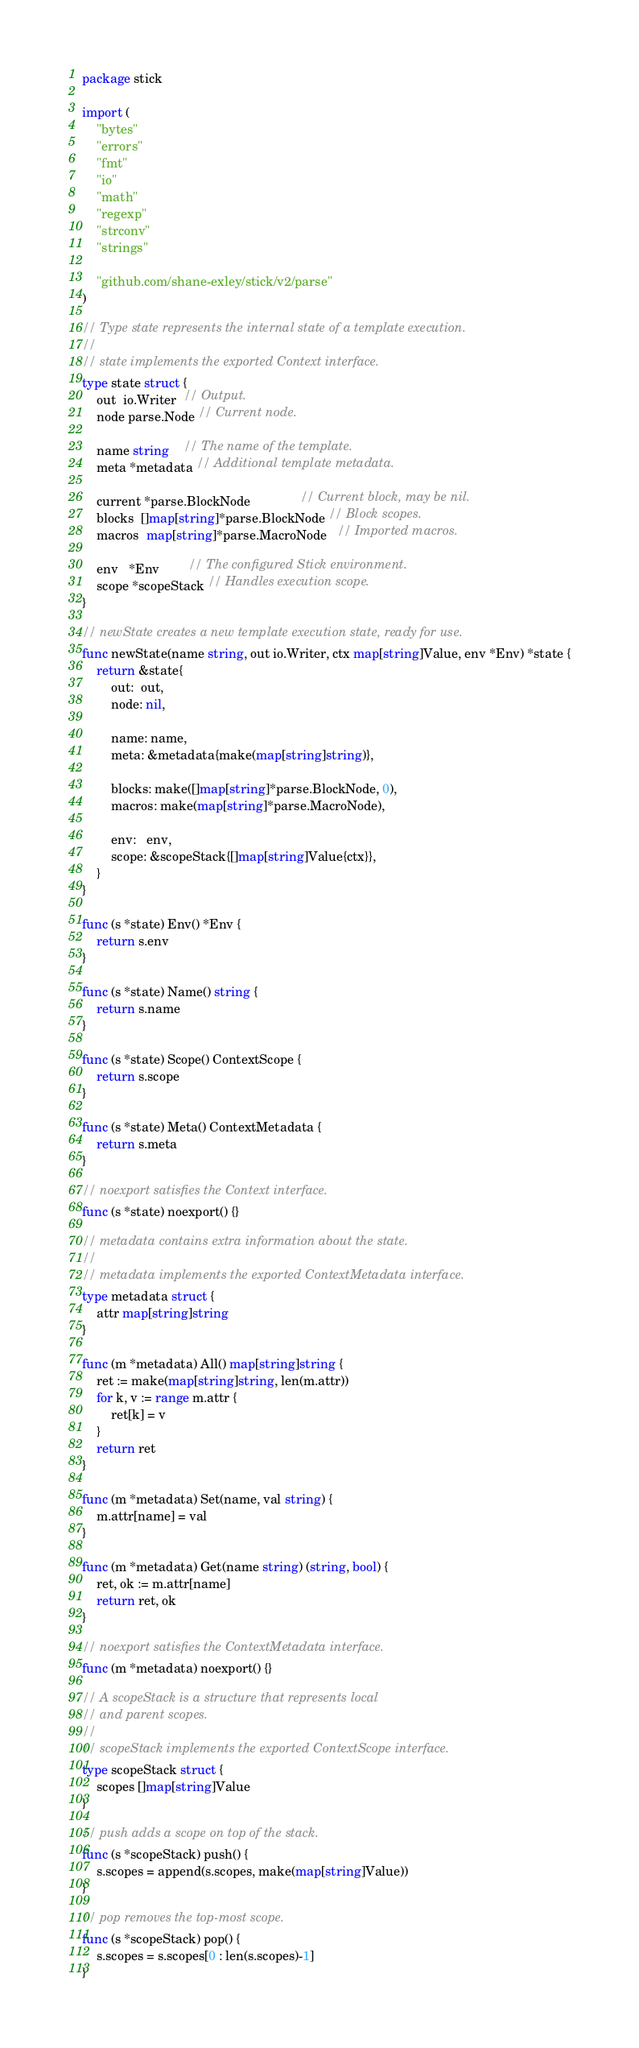Convert code to text. <code><loc_0><loc_0><loc_500><loc_500><_Go_>package stick

import (
	"bytes"
	"errors"
	"fmt"
	"io"
	"math"
	"regexp"
	"strconv"
	"strings"

	"github.com/shane-exley/stick/v2/parse"
)

// Type state represents the internal state of a template execution.
//
// state implements the exported Context interface.
type state struct {
	out  io.Writer  // Output.
	node parse.Node // Current node.

	name string    // The name of the template.
	meta *metadata // Additional template metadata.

	current *parse.BlockNode              // Current block, may be nil.
	blocks  []map[string]*parse.BlockNode // Block scopes.
	macros  map[string]*parse.MacroNode   // Imported macros.

	env   *Env        // The configured Stick environment.
	scope *scopeStack // Handles execution scope.
}

// newState creates a new template execution state, ready for use.
func newState(name string, out io.Writer, ctx map[string]Value, env *Env) *state {
	return &state{
		out:  out,
		node: nil,

		name: name,
		meta: &metadata{make(map[string]string)},

		blocks: make([]map[string]*parse.BlockNode, 0),
		macros: make(map[string]*parse.MacroNode),

		env:   env,
		scope: &scopeStack{[]map[string]Value{ctx}},
	}
}

func (s *state) Env() *Env {
	return s.env
}

func (s *state) Name() string {
	return s.name
}

func (s *state) Scope() ContextScope {
	return s.scope
}

func (s *state) Meta() ContextMetadata {
	return s.meta
}

// noexport satisfies the Context interface.
func (s *state) noexport() {}

// metadata contains extra information about the state.
//
// metadata implements the exported ContextMetadata interface.
type metadata struct {
	attr map[string]string
}

func (m *metadata) All() map[string]string {
	ret := make(map[string]string, len(m.attr))
	for k, v := range m.attr {
		ret[k] = v
	}
	return ret
}

func (m *metadata) Set(name, val string) {
	m.attr[name] = val
}

func (m *metadata) Get(name string) (string, bool) {
	ret, ok := m.attr[name]
	return ret, ok
}

// noexport satisfies the ContextMetadata interface.
func (m *metadata) noexport() {}

// A scopeStack is a structure that represents local
// and parent scopes.
//
// scopeStack implements the exported ContextScope interface.
type scopeStack struct {
	scopes []map[string]Value
}

// push adds a scope on top of the stack.
func (s *scopeStack) push() {
	s.scopes = append(s.scopes, make(map[string]Value))
}

// pop removes the top-most scope.
func (s *scopeStack) pop() {
	s.scopes = s.scopes[0 : len(s.scopes)-1]
}
</code> 